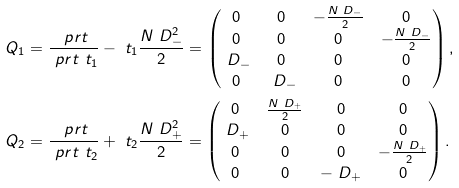Convert formula to latex. <formula><loc_0><loc_0><loc_500><loc_500>Q _ { 1 } & = \frac { \ p r t } { \ p r t \ t _ { 1 } } - \ t _ { 1 } \frac { N \ D _ { - } ^ { 2 } } { 2 } = \begin{pmatrix} 0 & 0 & - \frac { N \ D _ { - } } { 2 } & 0 \\ 0 & 0 & 0 & - \frac { N \ D _ { - } } { 2 } \\ \ D _ { - } & 0 & 0 & 0 \\ 0 & \ D _ { - } & 0 & 0 \end{pmatrix} , \\ Q _ { 2 } & = \frac { \ p r t } { \ p r t \ t _ { 2 } } + \ t _ { 2 } \frac { N \ D _ { + } ^ { 2 } } { 2 } = \begin{pmatrix} 0 & \frac { N \ D _ { + } } { 2 } & 0 & 0 \\ \ D _ { + } & 0 & 0 & 0 \\ 0 & 0 & 0 & - \frac { N \ D _ { + } } { 2 } \\ 0 & 0 & - \ D _ { + } & 0 \end{pmatrix} .</formula> 